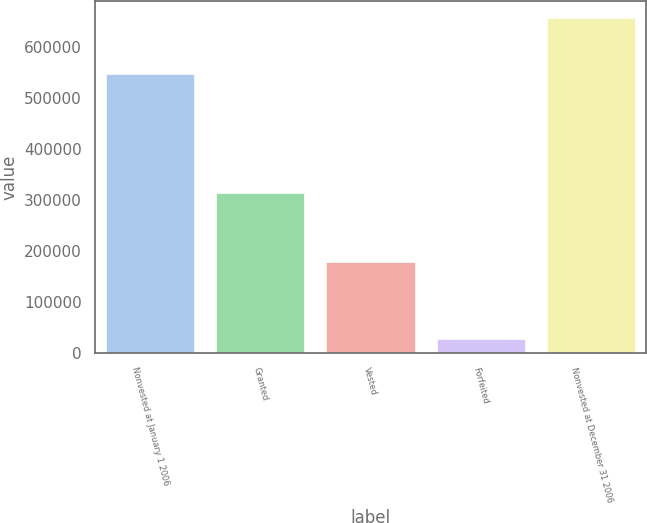<chart> <loc_0><loc_0><loc_500><loc_500><bar_chart><fcel>Nonvested at January 1 2006<fcel>Granted<fcel>Vested<fcel>Forfeited<fcel>Nonvested at December 31 2006<nl><fcel>547000<fcel>314000<fcel>177000<fcel>27000<fcel>657000<nl></chart> 